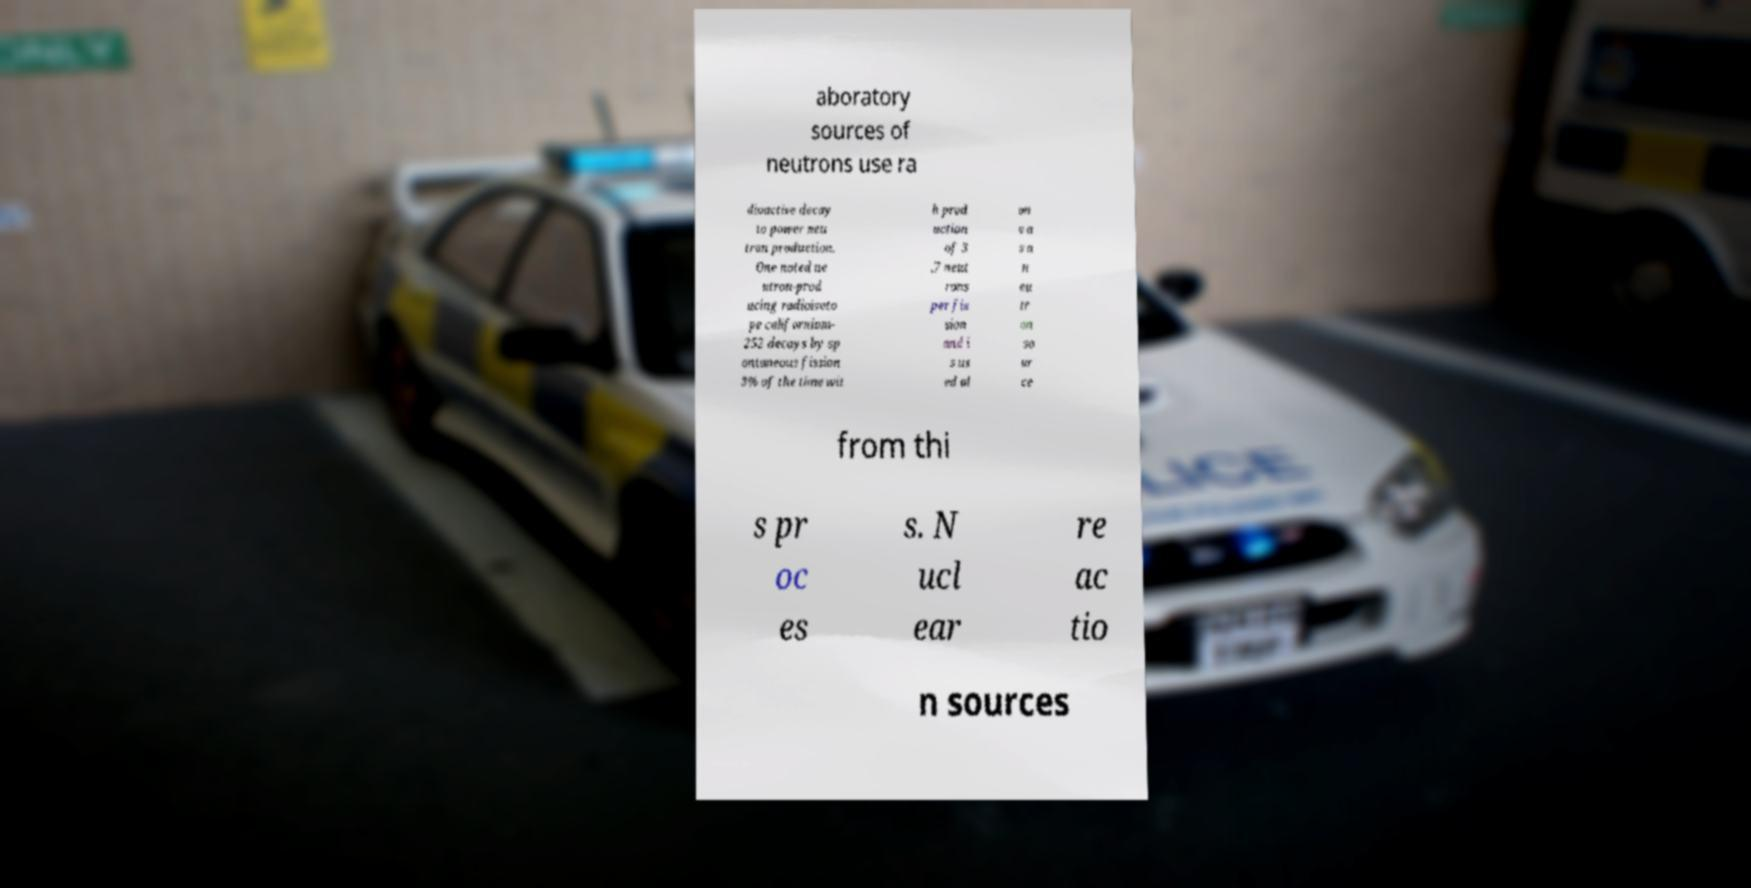Can you read and provide the text displayed in the image?This photo seems to have some interesting text. Can you extract and type it out for me? aboratory sources of neutrons use ra dioactive decay to power neu tron production. One noted ne utron-prod ucing radioisoto pe californium- 252 decays by sp ontaneous fission 3% of the time wit h prod uction of 3 .7 neut rons per fis sion and i s us ed al on e a s a n eu tr on so ur ce from thi s pr oc es s. N ucl ear re ac tio n sources 